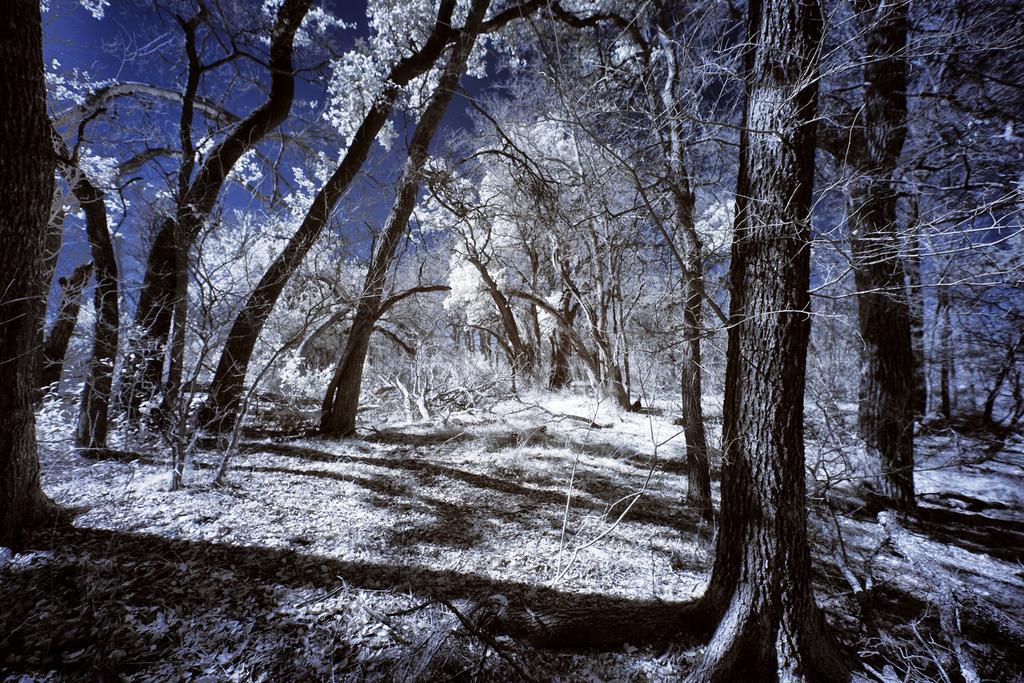Could you give a brief overview of what you see in this image? There are trees with the snow, at the top it is the sky in the night time. 